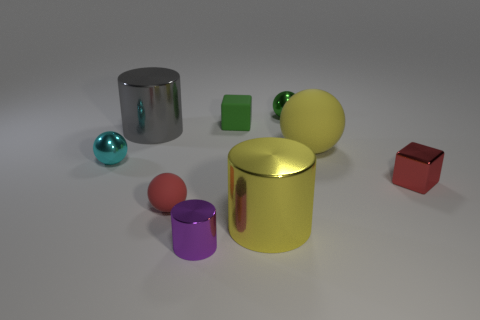Subtract all small balls. How many balls are left? 1 Subtract all green blocks. How many blocks are left? 1 Add 1 small purple cylinders. How many objects exist? 10 Subtract 2 cylinders. How many cylinders are left? 1 Subtract all matte spheres. Subtract all big blue spheres. How many objects are left? 7 Add 8 purple things. How many purple things are left? 9 Add 1 purple metallic cylinders. How many purple metallic cylinders exist? 2 Subtract 1 purple cylinders. How many objects are left? 8 Subtract all spheres. How many objects are left? 5 Subtract all brown cylinders. Subtract all purple blocks. How many cylinders are left? 3 